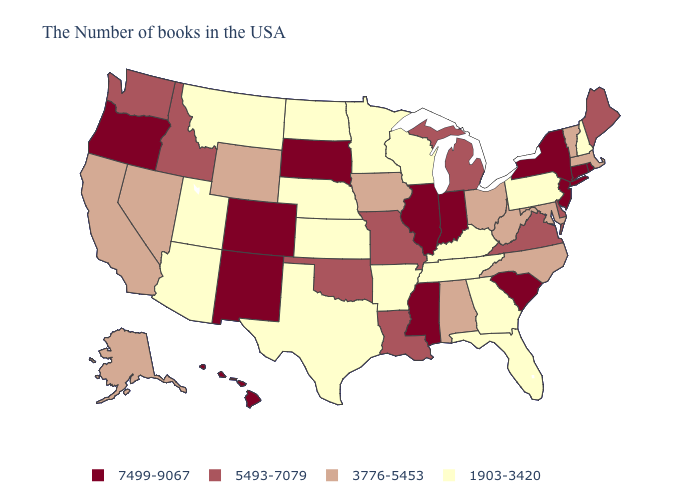Name the states that have a value in the range 5493-7079?
Be succinct. Maine, Delaware, Virginia, Michigan, Louisiana, Missouri, Oklahoma, Idaho, Washington. What is the value of Missouri?
Write a very short answer. 5493-7079. What is the value of Louisiana?
Keep it brief. 5493-7079. What is the highest value in the USA?
Keep it brief. 7499-9067. What is the highest value in the West ?
Be succinct. 7499-9067. What is the highest value in the West ?
Short answer required. 7499-9067. How many symbols are there in the legend?
Concise answer only. 4. What is the value of South Carolina?
Answer briefly. 7499-9067. What is the highest value in the MidWest ?
Concise answer only. 7499-9067. Name the states that have a value in the range 7499-9067?
Keep it brief. Rhode Island, Connecticut, New York, New Jersey, South Carolina, Indiana, Illinois, Mississippi, South Dakota, Colorado, New Mexico, Oregon, Hawaii. What is the value of Delaware?
Quick response, please. 5493-7079. Name the states that have a value in the range 1903-3420?
Quick response, please. New Hampshire, Pennsylvania, Florida, Georgia, Kentucky, Tennessee, Wisconsin, Arkansas, Minnesota, Kansas, Nebraska, Texas, North Dakota, Utah, Montana, Arizona. What is the value of North Dakota?
Be succinct. 1903-3420. Is the legend a continuous bar?
Short answer required. No. Among the states that border Idaho , does Utah have the lowest value?
Concise answer only. Yes. 